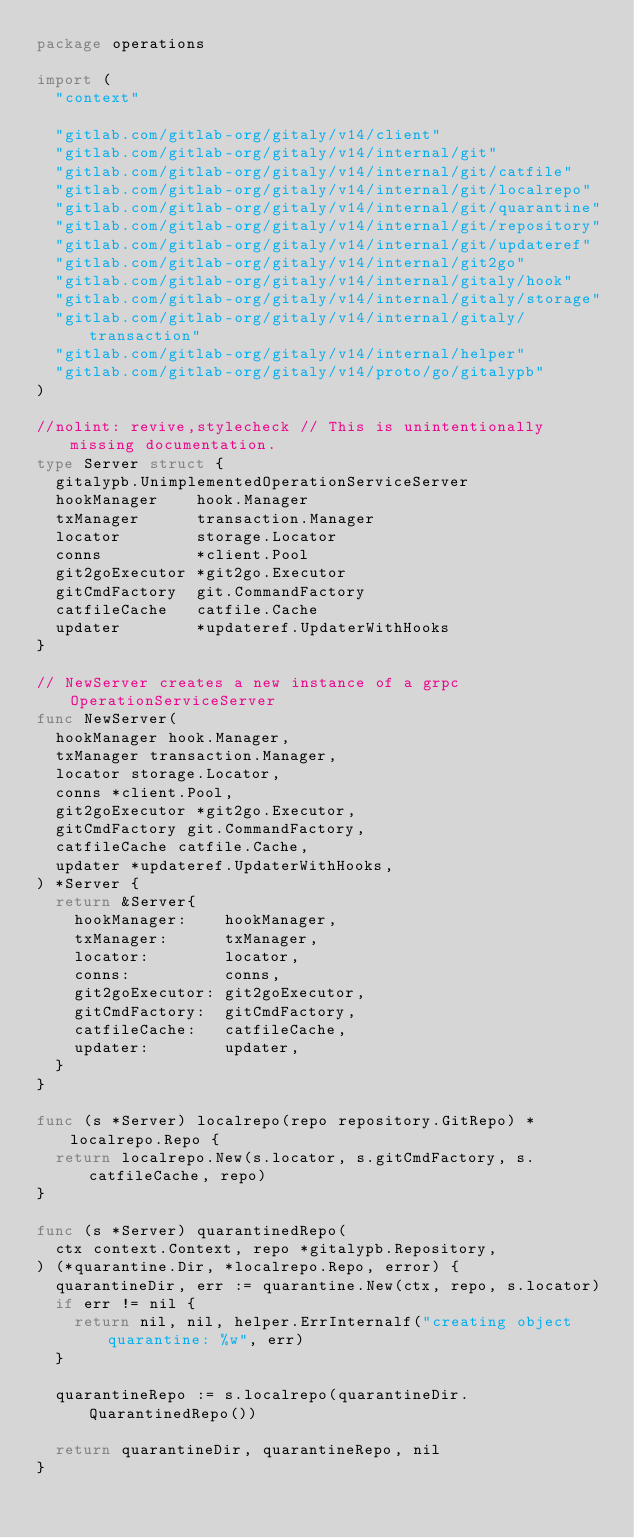<code> <loc_0><loc_0><loc_500><loc_500><_Go_>package operations

import (
	"context"

	"gitlab.com/gitlab-org/gitaly/v14/client"
	"gitlab.com/gitlab-org/gitaly/v14/internal/git"
	"gitlab.com/gitlab-org/gitaly/v14/internal/git/catfile"
	"gitlab.com/gitlab-org/gitaly/v14/internal/git/localrepo"
	"gitlab.com/gitlab-org/gitaly/v14/internal/git/quarantine"
	"gitlab.com/gitlab-org/gitaly/v14/internal/git/repository"
	"gitlab.com/gitlab-org/gitaly/v14/internal/git/updateref"
	"gitlab.com/gitlab-org/gitaly/v14/internal/git2go"
	"gitlab.com/gitlab-org/gitaly/v14/internal/gitaly/hook"
	"gitlab.com/gitlab-org/gitaly/v14/internal/gitaly/storage"
	"gitlab.com/gitlab-org/gitaly/v14/internal/gitaly/transaction"
	"gitlab.com/gitlab-org/gitaly/v14/internal/helper"
	"gitlab.com/gitlab-org/gitaly/v14/proto/go/gitalypb"
)

//nolint: revive,stylecheck // This is unintentionally missing documentation.
type Server struct {
	gitalypb.UnimplementedOperationServiceServer
	hookManager    hook.Manager
	txManager      transaction.Manager
	locator        storage.Locator
	conns          *client.Pool
	git2goExecutor *git2go.Executor
	gitCmdFactory  git.CommandFactory
	catfileCache   catfile.Cache
	updater        *updateref.UpdaterWithHooks
}

// NewServer creates a new instance of a grpc OperationServiceServer
func NewServer(
	hookManager hook.Manager,
	txManager transaction.Manager,
	locator storage.Locator,
	conns *client.Pool,
	git2goExecutor *git2go.Executor,
	gitCmdFactory git.CommandFactory,
	catfileCache catfile.Cache,
	updater *updateref.UpdaterWithHooks,
) *Server {
	return &Server{
		hookManager:    hookManager,
		txManager:      txManager,
		locator:        locator,
		conns:          conns,
		git2goExecutor: git2goExecutor,
		gitCmdFactory:  gitCmdFactory,
		catfileCache:   catfileCache,
		updater:        updater,
	}
}

func (s *Server) localrepo(repo repository.GitRepo) *localrepo.Repo {
	return localrepo.New(s.locator, s.gitCmdFactory, s.catfileCache, repo)
}

func (s *Server) quarantinedRepo(
	ctx context.Context, repo *gitalypb.Repository,
) (*quarantine.Dir, *localrepo.Repo, error) {
	quarantineDir, err := quarantine.New(ctx, repo, s.locator)
	if err != nil {
		return nil, nil, helper.ErrInternalf("creating object quarantine: %w", err)
	}

	quarantineRepo := s.localrepo(quarantineDir.QuarantinedRepo())

	return quarantineDir, quarantineRepo, nil
}
</code> 